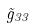<formula> <loc_0><loc_0><loc_500><loc_500>\tilde { g } _ { 3 3 }</formula> 